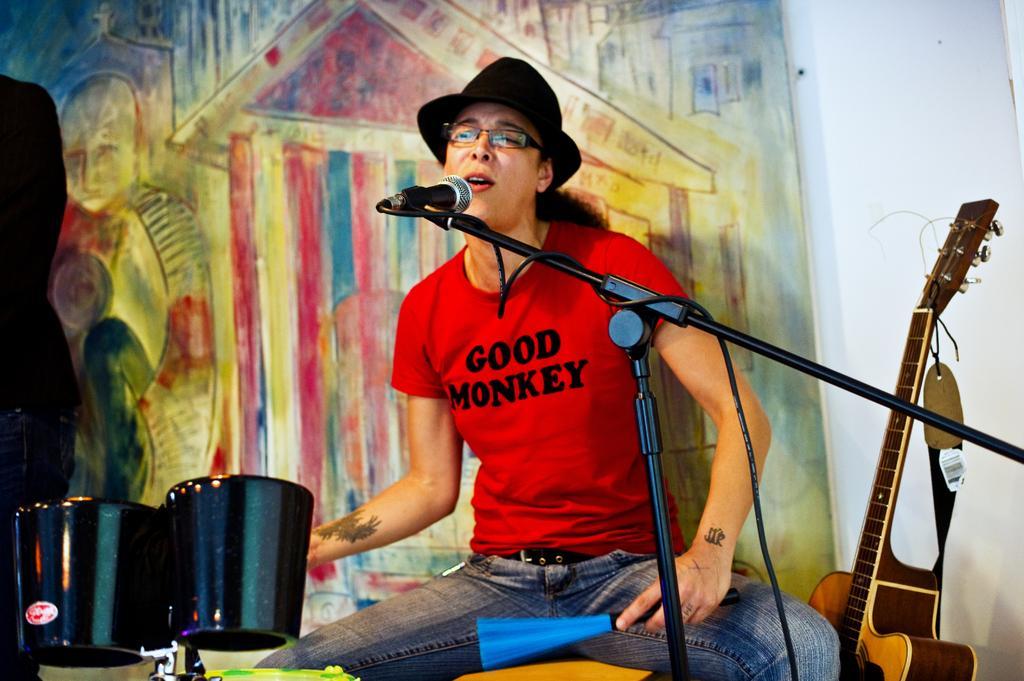How would you summarize this image in a sentence or two? In a picture a woman present in the centre and she is sitting on a chair and wearing red t-shirt and jeans and singing a song in the microphone beside her there is guitar and the left corner there is one person is standing and there are drums and behind them there is wall painted in colours. 